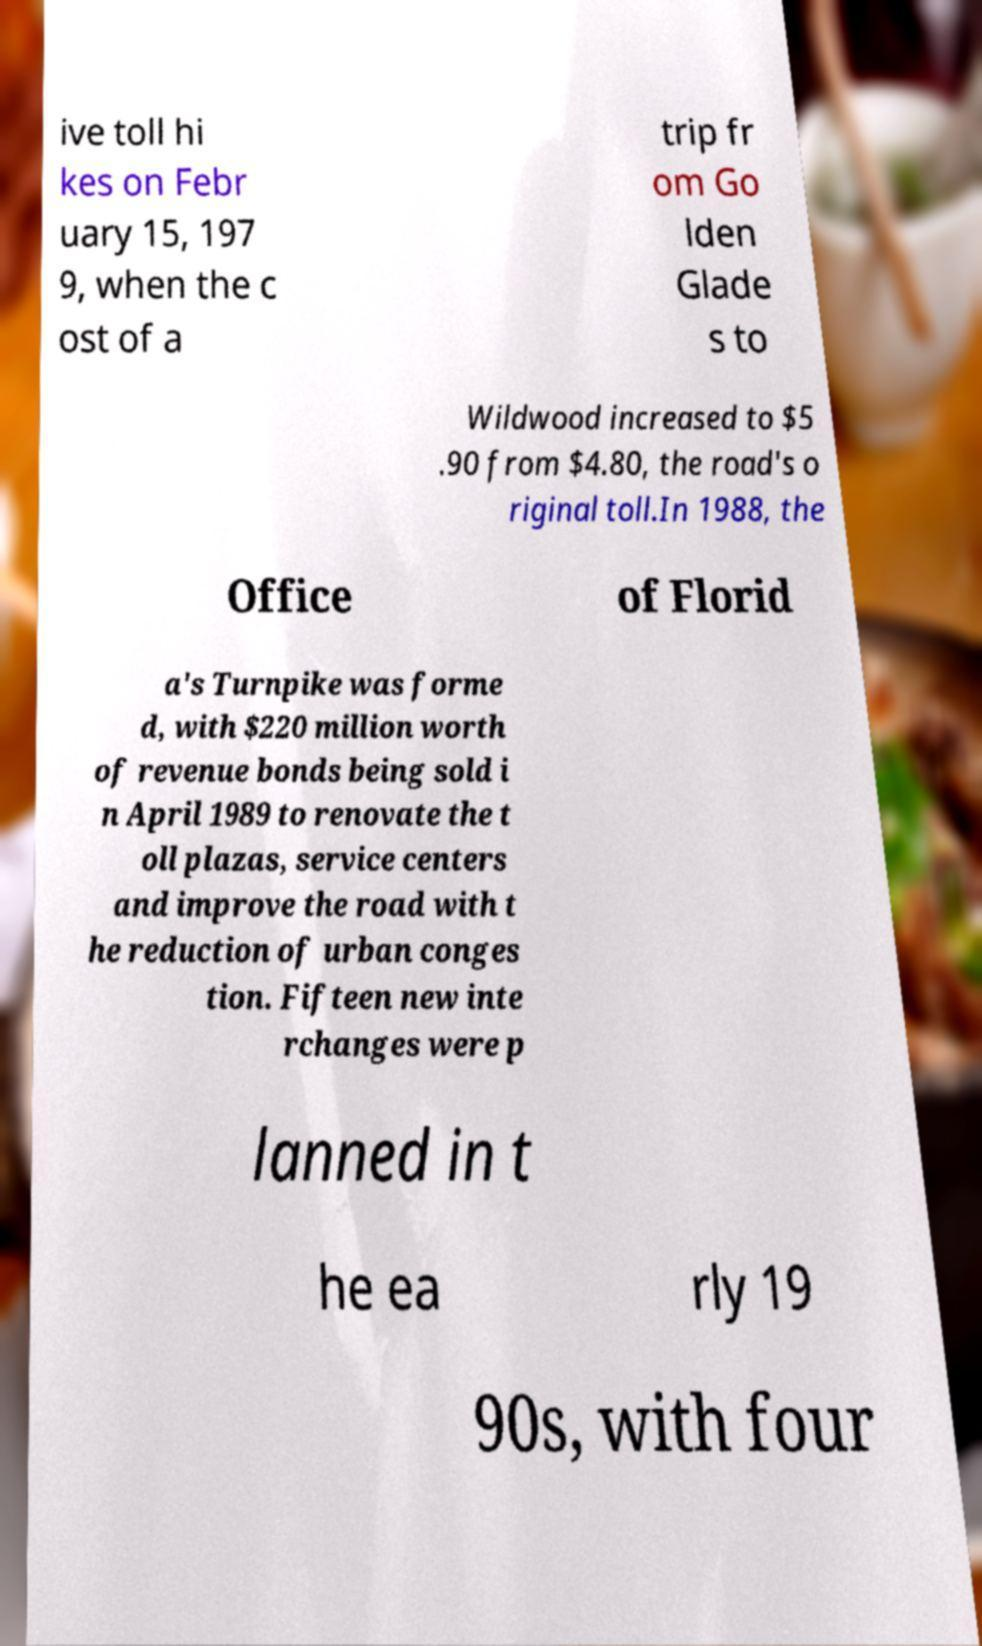What messages or text are displayed in this image? I need them in a readable, typed format. ive toll hi kes on Febr uary 15, 197 9, when the c ost of a trip fr om Go lden Glade s to Wildwood increased to $5 .90 from $4.80, the road's o riginal toll.In 1988, the Office of Florid a's Turnpike was forme d, with $220 million worth of revenue bonds being sold i n April 1989 to renovate the t oll plazas, service centers and improve the road with t he reduction of urban conges tion. Fifteen new inte rchanges were p lanned in t he ea rly 19 90s, with four 